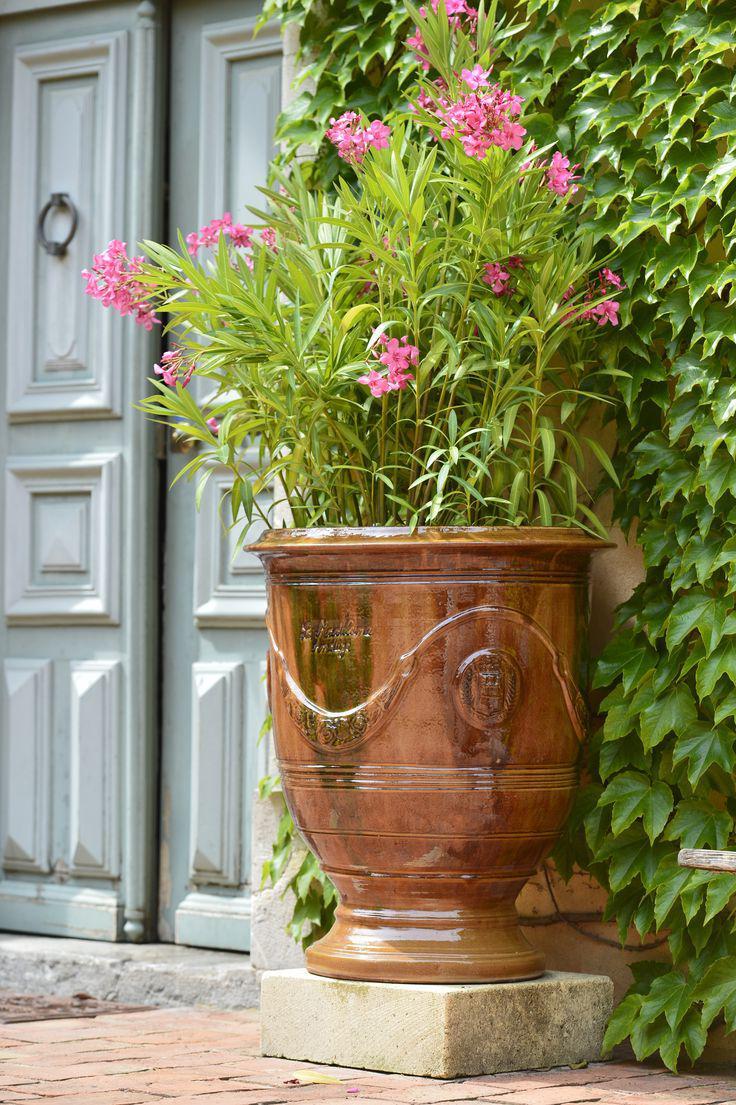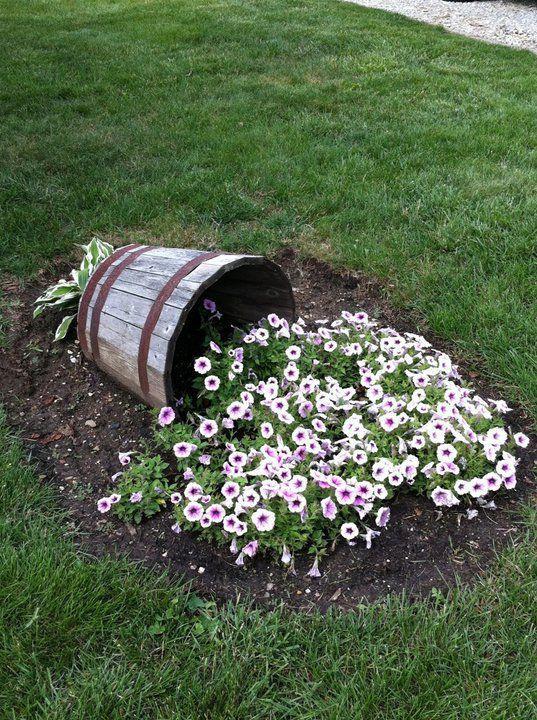The first image is the image on the left, the second image is the image on the right. Evaluate the accuracy of this statement regarding the images: "One image includes a shiny greenish vessel used as an outdoor fountain, and the other image shows a flower-filled stone-look planter with a pedestal base.". Is it true? Answer yes or no. No. The first image is the image on the left, the second image is the image on the right. Considering the images on both sides, is "There is a vase that holds a water  fountain ." valid? Answer yes or no. No. 